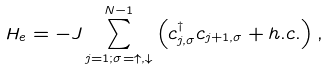Convert formula to latex. <formula><loc_0><loc_0><loc_500><loc_500>H _ { e } = - J \sum _ { j = 1 ; \sigma = \uparrow , \downarrow } ^ { N - 1 } \left ( c _ { j , \sigma } ^ { \dagger } c _ { j + 1 , \sigma } + h . c . \right ) ,</formula> 